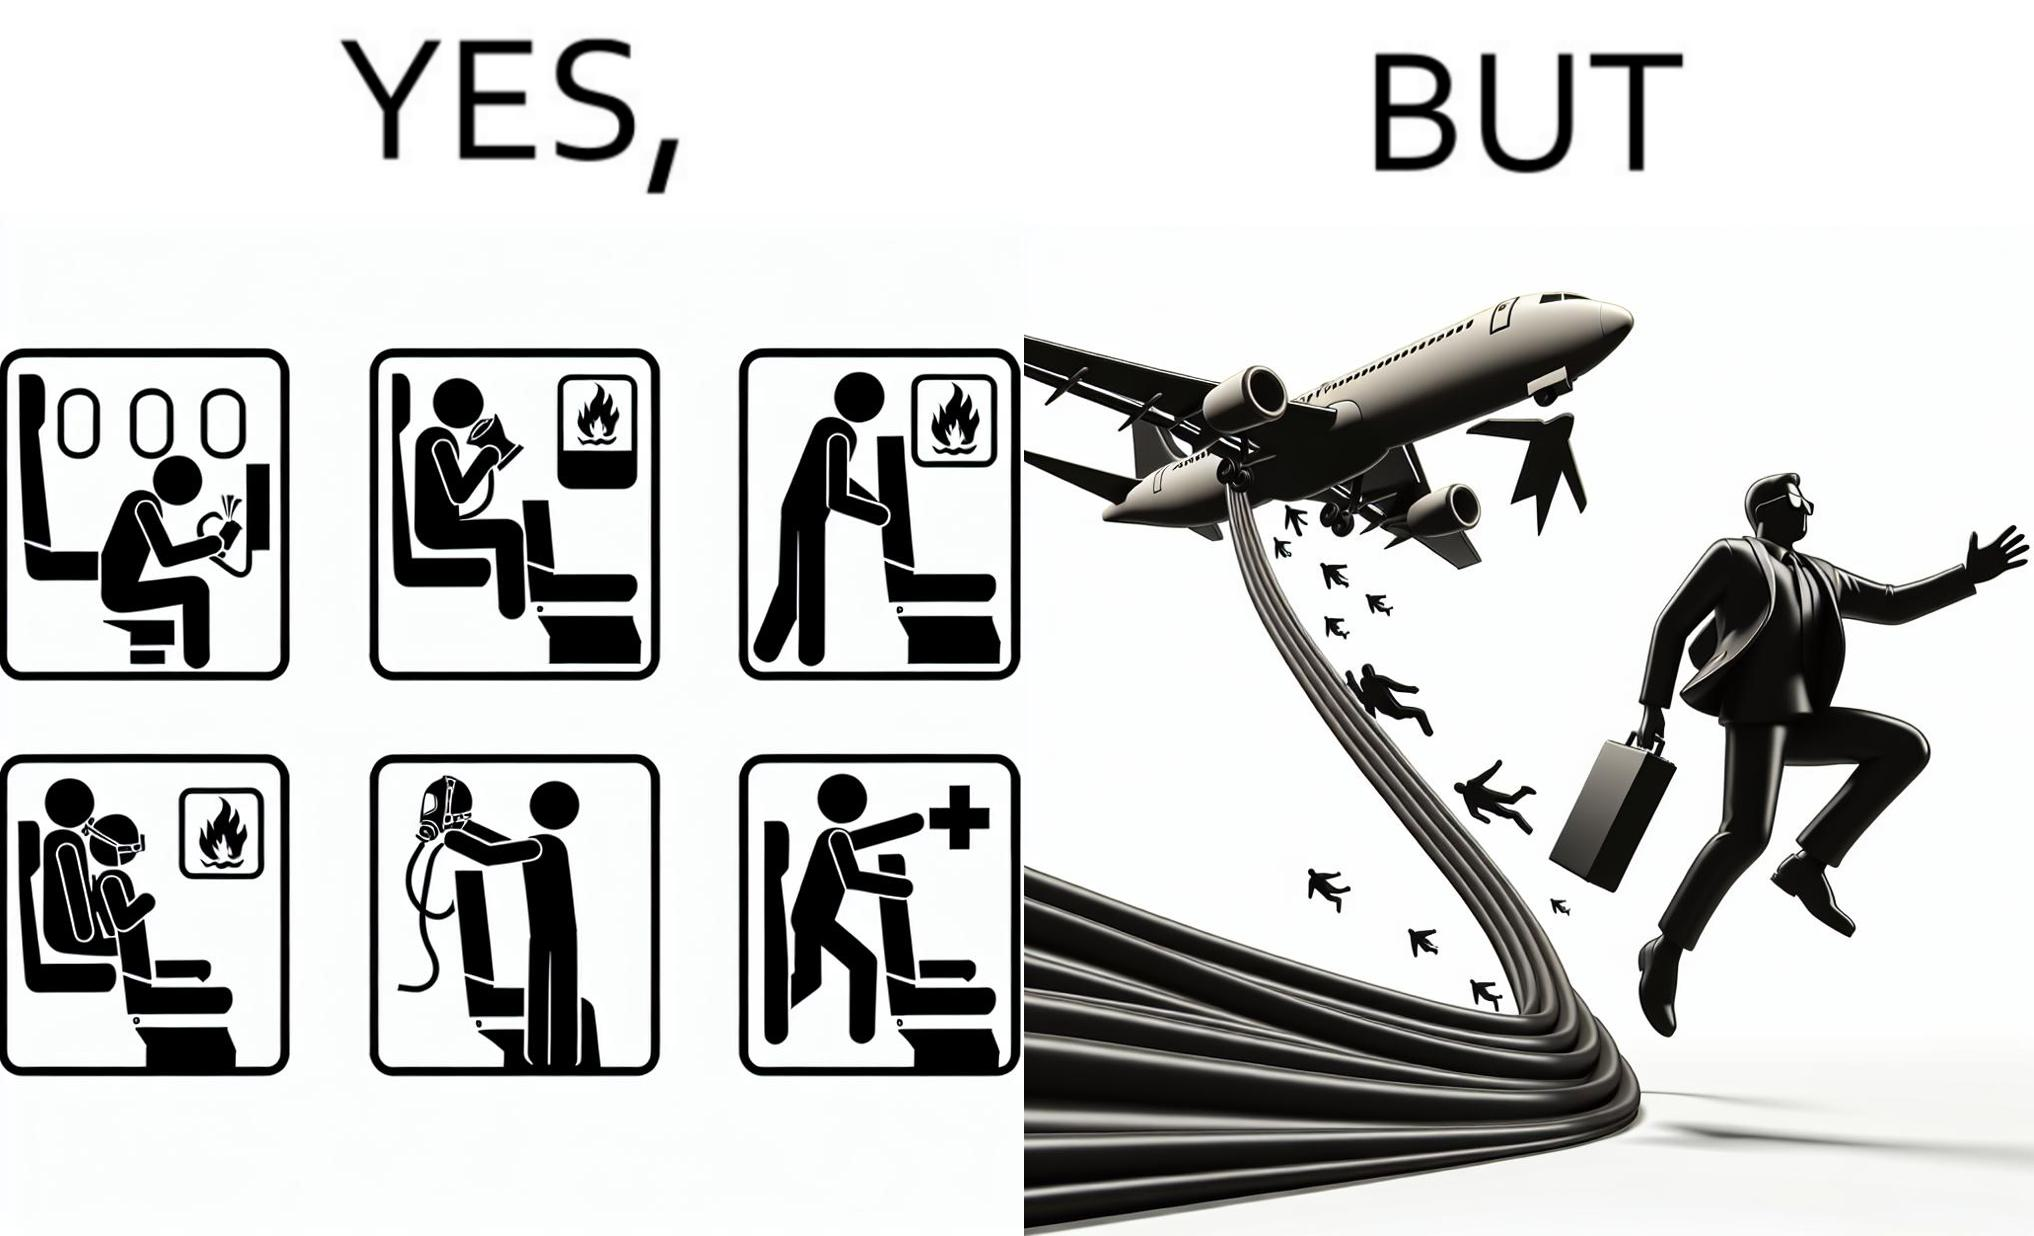Explain the humor or irony in this image. These images are funny since it shows how we are taught emergency procedures to follow in case of an accident while in an airplane but how none of them work if the plane is still in air 